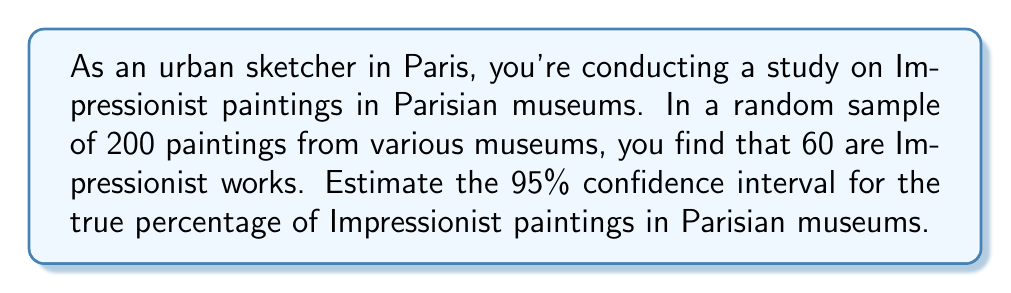Solve this math problem. Let's approach this step-by-step:

1) First, we calculate the sample proportion:
   $\hat{p} = \frac{60}{200} = 0.30$ or 30%

2) The sample size $n = 200$

3) For a 95% confidence interval, we use $z = 1.96$

4) The formula for the confidence interval is:

   $$\hat{p} \pm z\sqrt{\frac{\hat{p}(1-\hat{p})}{n}}$$

5) Let's calculate the margin of error:

   $$1.96\sqrt{\frac{0.30(1-0.30)}{200}} = 1.96\sqrt{\frac{0.21}{200}} = 1.96 \times 0.0324 = 0.0635$$

6) Now we can calculate the confidence interval:

   Lower bound: $0.30 - 0.0635 = 0.2365$ or 23.65%
   Upper bound: $0.30 + 0.0635 = 0.3635$ or 36.35%

7) Therefore, we can say with 95% confidence that the true percentage of Impressionist paintings in Parisian museums is between 23.65% and 36.35%.
Answer: (23.65%, 36.35%) 